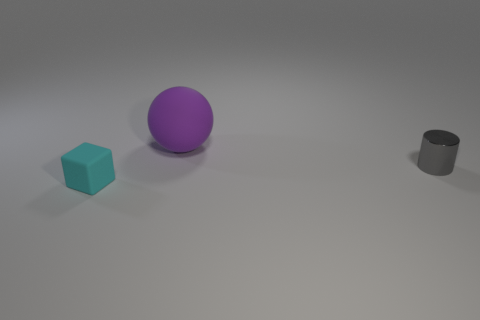Subtract all blue cylinders. Subtract all gray cubes. How many cylinders are left? 1 Subtract all yellow cylinders. How many gray spheres are left? 0 Add 3 tiny objects. How many big purples exist? 0 Subtract all small blocks. Subtract all small matte cubes. How many objects are left? 1 Add 1 balls. How many balls are left? 2 Add 3 small gray cylinders. How many small gray cylinders exist? 4 Add 3 tiny cyan blocks. How many objects exist? 6 Subtract 1 purple balls. How many objects are left? 2 Subtract all spheres. How many objects are left? 2 Subtract 1 blocks. How many blocks are left? 0 